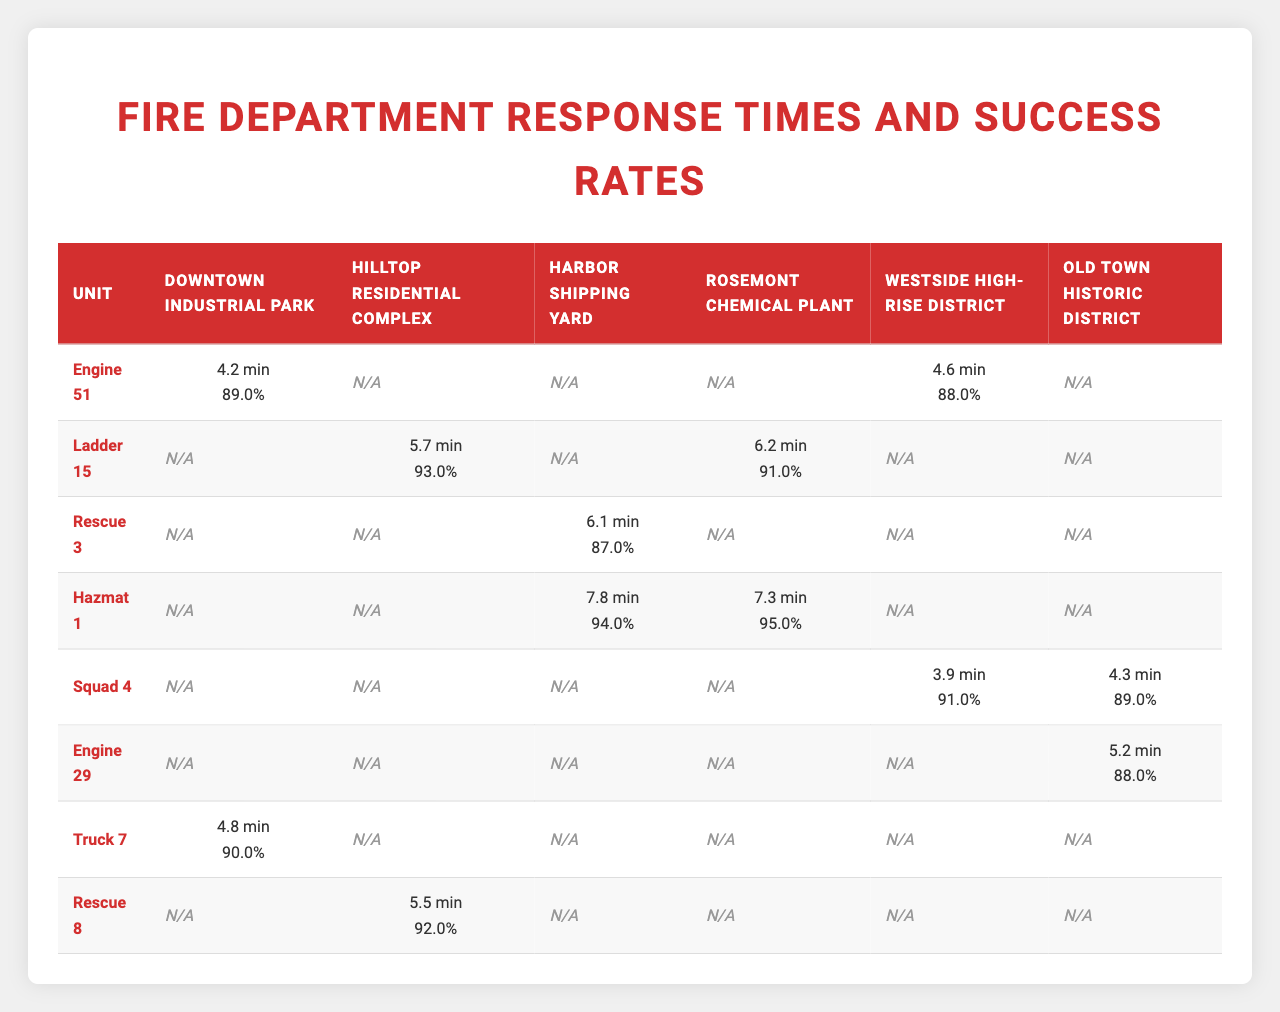What is the response time for Engine 51 in Downtown Industrial Park? The table shows the response time for Engine 51 in Downtown Industrial Park as 4.2 minutes.
Answer: 4.2 minutes Which unit has the highest success rate in the Harbor Shipping Yard? The success rates for the units in the Harbor Shipping Yard are: Rescue 3 (87%) and Hazmat 1 (94%). Hazmat 1 has the highest success rate at 94%.
Answer: Hazmat 1 What is the average response time for Ladder 15 across different areas? The response times for Ladder 15 are 5.7 minutes in Hilltop Residential Complex and 6.2 minutes in Rosemont Chemical Plant. The average response time is (5.7 + 6.2) / 2 = 5.95 minutes.
Answer: 5.95 minutes Does Engine 29 have a higher success rate in Old Town Historic District compared to Squad 4? Engine 29 has a success rate of 88% and Squad 4 has a success rate of 89% in Old Town Historic District. Therefore, Engine 29 does not have a higher success rate.
Answer: No What is the difference in response times between Rescue 3 and Hazmat 1 in the Harbor Shipping Yard? The response time for Rescue 3 is 6.1 minutes and for Hazmat 1 it is 7.8 minutes. The difference is 7.8 - 6.1 = 1.7 minutes.
Answer: 1.7 minutes Which unit responded the quickest in the Westside High-Rise District? The response times in the Westside High-Rise District are: Engine 51 (4.6 minutes) and Squad 4 (3.9 minutes). Squad 4 responded quickest at 3.9 minutes.
Answer: Squad 4 What percentage of the units have a success rate above 90% in the Downtown Industrial Park? The units in Downtown Industrial Park are Engine 51 (89%) and Truck 7 (90%). Only Truck 7 has a success rate above 90%. Of the 2 units, 1 has above 90%, so the percentage is (1/2) * 100 = 50%.
Answer: 50% Which area has the lowest average response time when considering all units? The response times for each area are as follows: Downtown Industrial Park (4.2 + 4.8) / 2 = 4.5 minutes, Hilltop Residential Complex (5.7 + 5.5) / 2 = 5.6 minutes, Harbor Shipping Yard (6.1 + 7.8) / 2 = 6.95 minutes, Rosemont Chemical Plant (7.3 + 6.2) / 2 = 6.75 minutes, Westside High-Rise District (3.9 + 4.6) / 2 = 4.25 minutes, Old Town Historic District (5.2 + 4.3) / 2 = 4.75 minutes. Westside High-Rise District has the lowest average response time of 4.25 minutes.
Answer: Westside High-Rise District Does Hazmat 1 have a better success rate than Engine 51 overall? Hazmat 1 has success rates of 95% in Rosemont Chemical Plant and 94% in Harbor Shipping Yard, while Engine 51 has success rates of 89% in Downtown Industrial Park and 88% in Westside High-Rise District. Hazmat 1's average success rate is (95 + 94) / 2 = 94.5% and Engine 51's average is (89 + 88) / 2 = 88.5%. Hazmat 1 has a better success rate.
Answer: Yes Which unit has had the highest response time in the Rosemont Chemical Plant? In Rosemont Chemical Plant, Ladder 15's response time is 6.2 minutes and Hazmat 1's is 7.3 minutes. Therefore, Hazmat 1 has the highest response time at 7.3 minutes.
Answer: Hazmat 1 